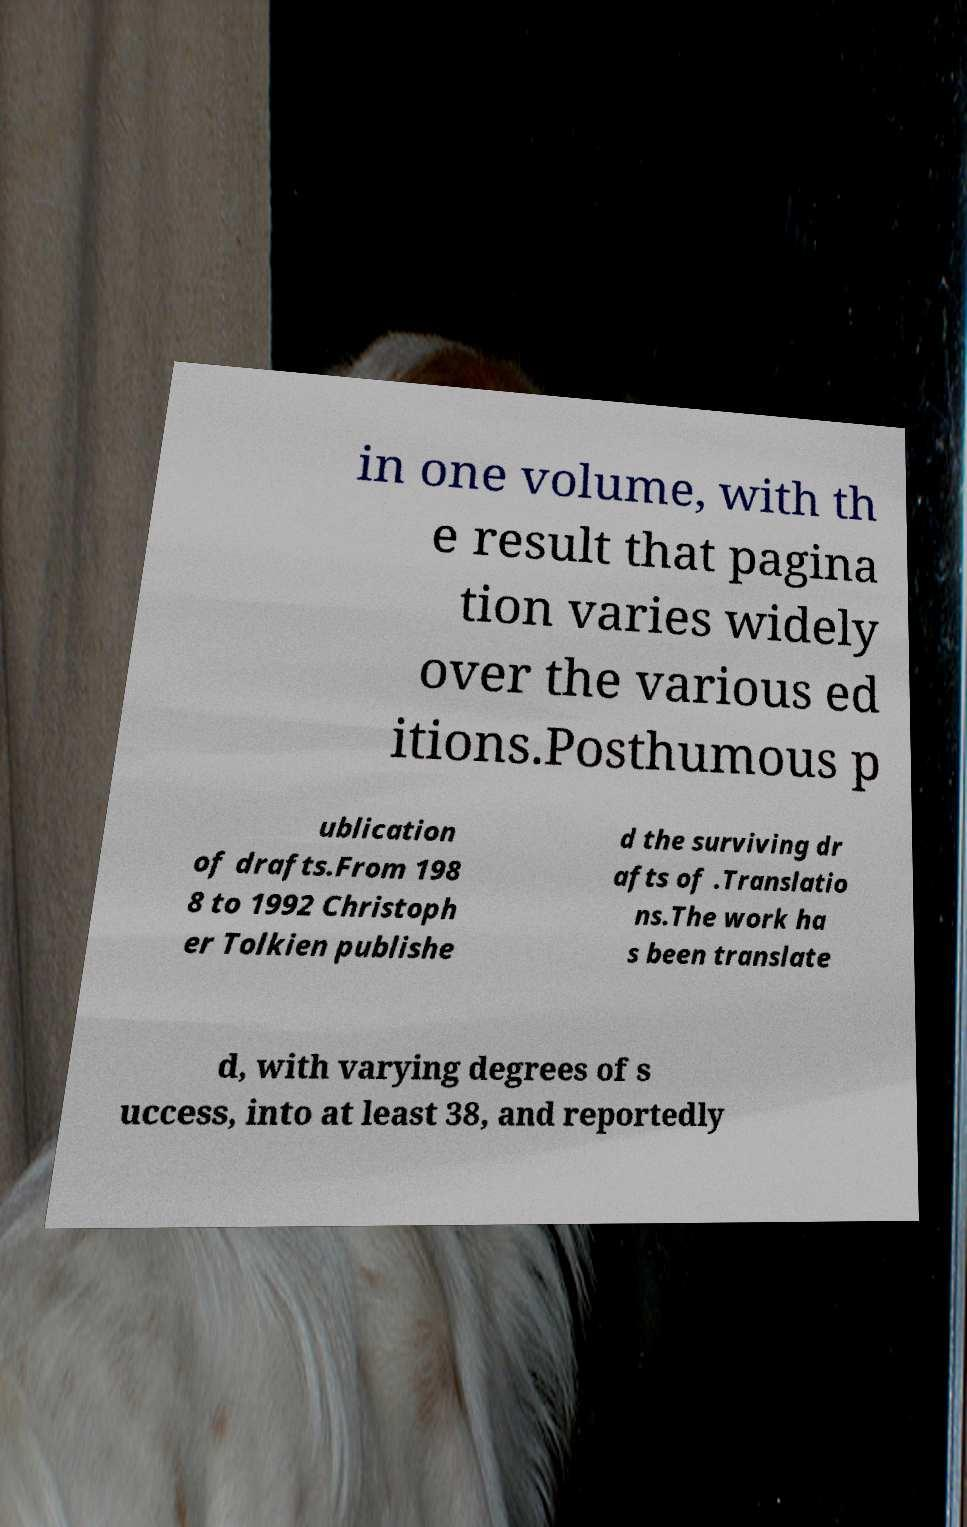For documentation purposes, I need the text within this image transcribed. Could you provide that? in one volume, with th e result that pagina tion varies widely over the various ed itions.Posthumous p ublication of drafts.From 198 8 to 1992 Christoph er Tolkien publishe d the surviving dr afts of .Translatio ns.The work ha s been translate d, with varying degrees of s uccess, into at least 38, and reportedly 